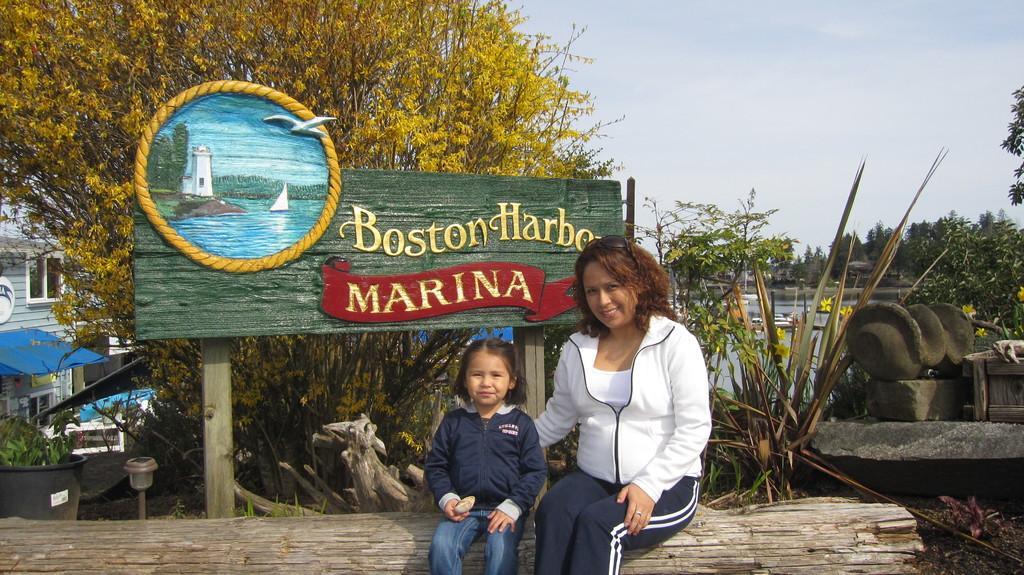Describe this image in one or two sentences. In this image in the front there are persons sitting and smiling. In the center there is a board with some text written on it and there are plants. In the background there are trees and on the left side there is a building and there is a plant in the pot and the sky is cloudy. 